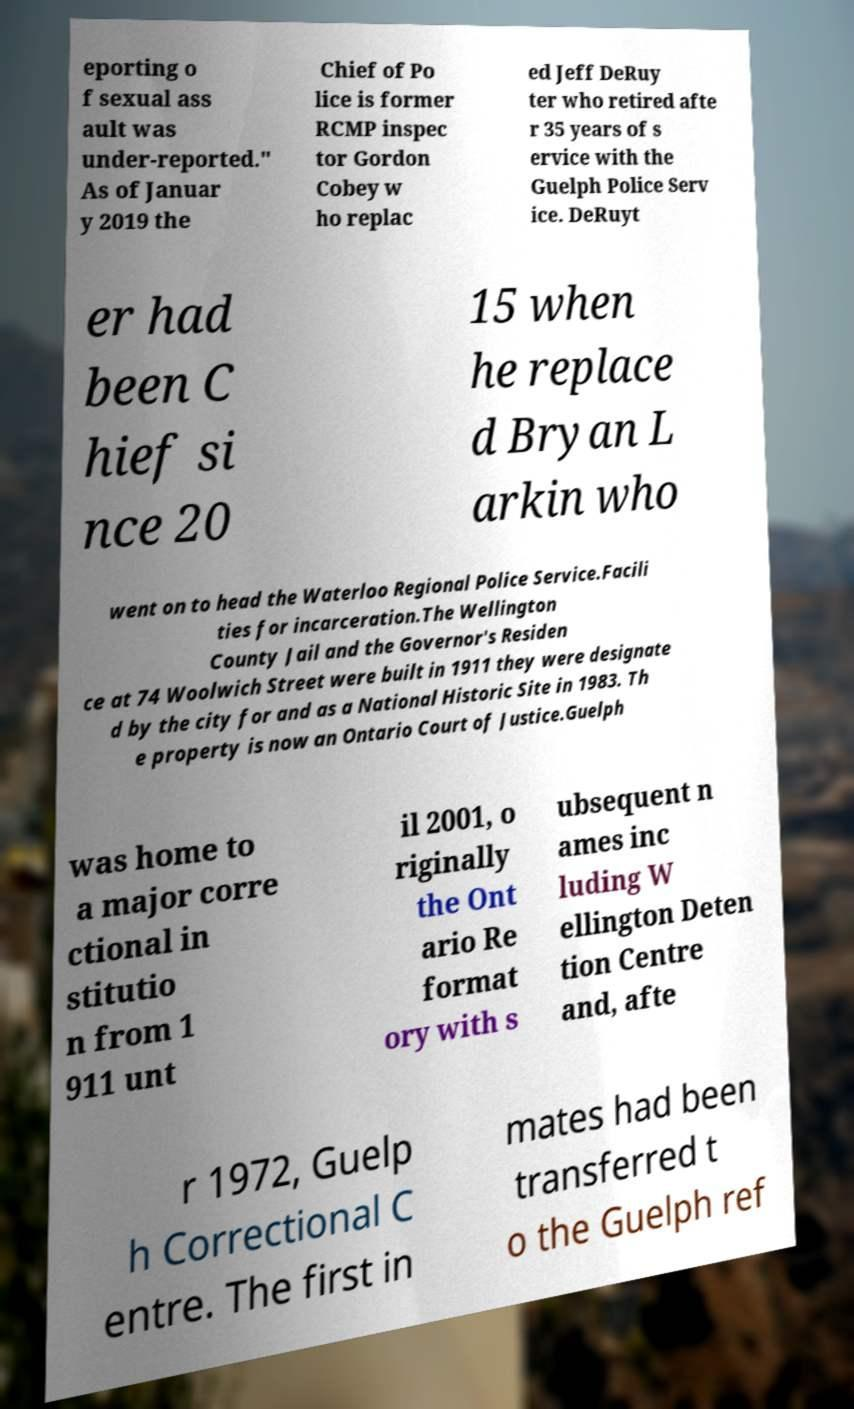Could you extract and type out the text from this image? eporting o f sexual ass ault was under-reported." As of Januar y 2019 the Chief of Po lice is former RCMP inspec tor Gordon Cobey w ho replac ed Jeff DeRuy ter who retired afte r 35 years of s ervice with the Guelph Police Serv ice. DeRuyt er had been C hief si nce 20 15 when he replace d Bryan L arkin who went on to head the Waterloo Regional Police Service.Facili ties for incarceration.The Wellington County Jail and the Governor's Residen ce at 74 Woolwich Street were built in 1911 they were designate d by the city for and as a National Historic Site in 1983. Th e property is now an Ontario Court of Justice.Guelph was home to a major corre ctional in stitutio n from 1 911 unt il 2001, o riginally the Ont ario Re format ory with s ubsequent n ames inc luding W ellington Deten tion Centre and, afte r 1972, Guelp h Correctional C entre. The first in mates had been transferred t o the Guelph ref 